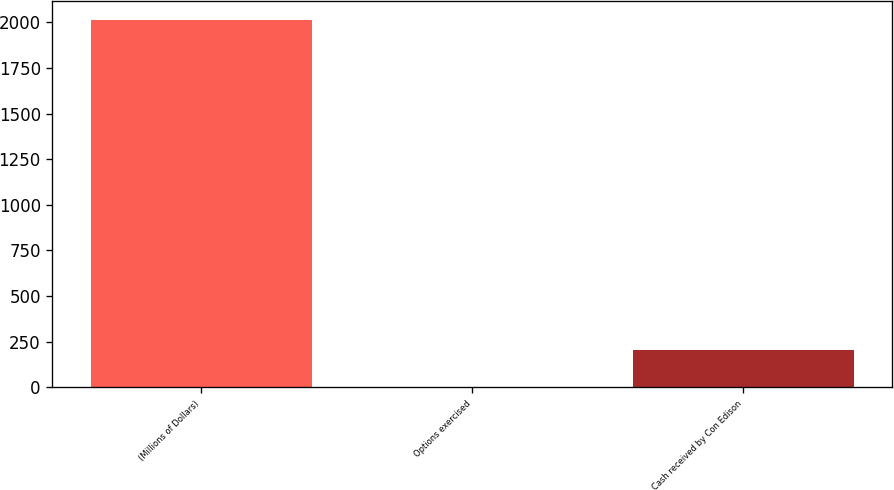Convert chart to OTSL. <chart><loc_0><loc_0><loc_500><loc_500><bar_chart><fcel>(Millions of Dollars)<fcel>Options exercised<fcel>Cash received by Con Edison<nl><fcel>2015<fcel>3<fcel>204.2<nl></chart> 